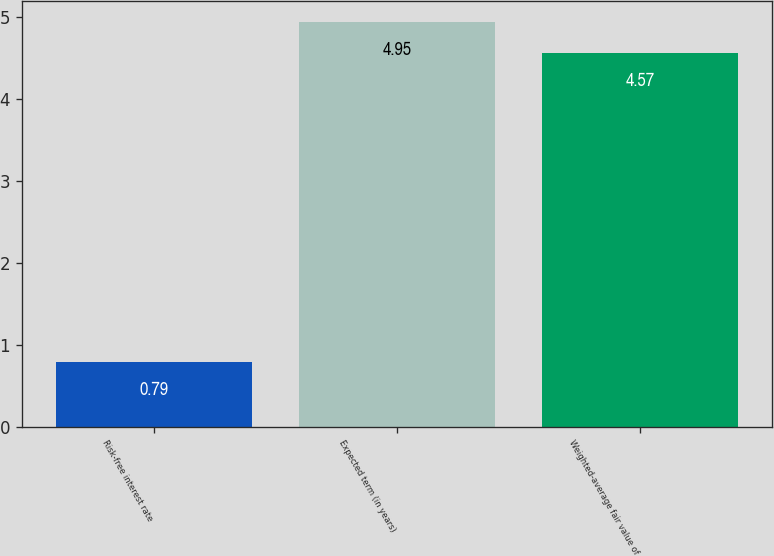Convert chart. <chart><loc_0><loc_0><loc_500><loc_500><bar_chart><fcel>Risk-free interest rate<fcel>Expected term (in years)<fcel>Weighted-average fair value of<nl><fcel>0.79<fcel>4.95<fcel>4.57<nl></chart> 